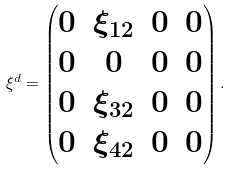Convert formula to latex. <formula><loc_0><loc_0><loc_500><loc_500>\xi ^ { d } = \begin{pmatrix} 0 & \xi _ { 1 2 } & 0 & 0 \\ 0 & 0 & 0 & 0 \\ 0 & \xi _ { 3 2 } & 0 & 0 \\ 0 & \xi _ { 4 2 } & 0 & 0 \\ \end{pmatrix} .</formula> 